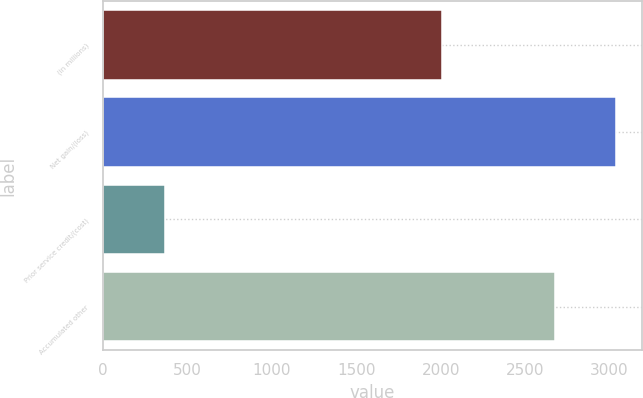Convert chart. <chart><loc_0><loc_0><loc_500><loc_500><bar_chart><fcel>(in millions)<fcel>Net gain/(loss)<fcel>Prior service credit/(cost)<fcel>Accumulated other<nl><fcel>2009<fcel>3039<fcel>364<fcel>2675<nl></chart> 